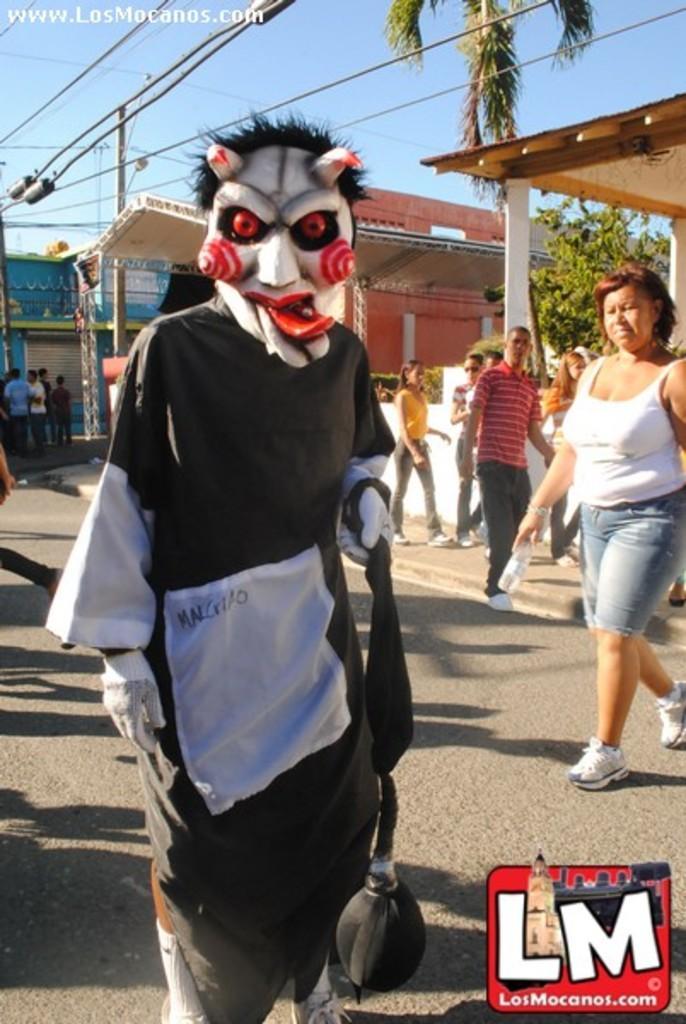Describe this image in one or two sentences. Front this person wore a mask. Background there are people, buildings and trees.  